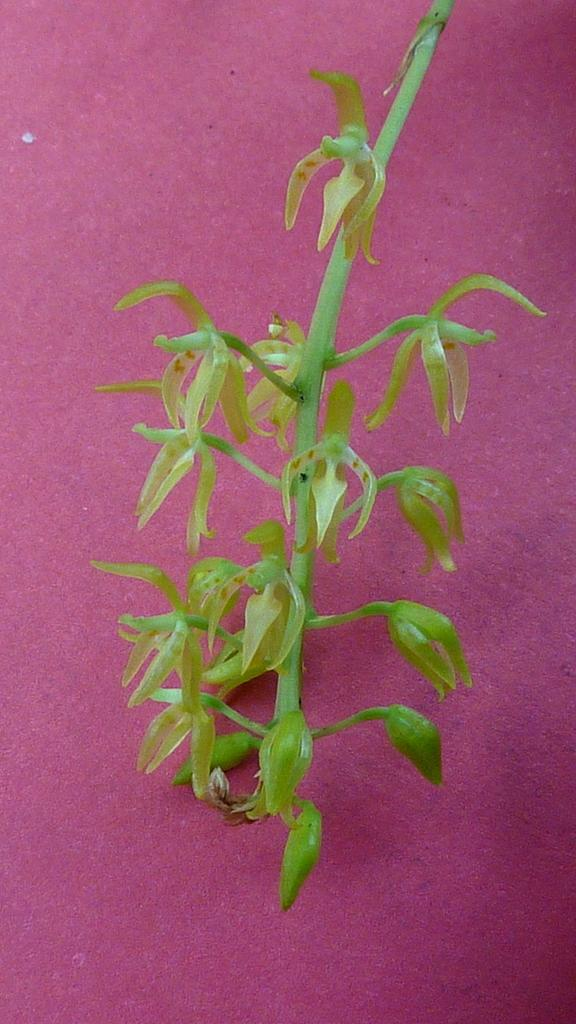What is present in the image? There is a plant in the image. What color is the plant? The plant is green in color. What is the plant placed on? The plant is on a pink surface. Can you see a stranger making an adjustment to the plant in the image? There is no stranger present in the image, nor is anyone making an adjustment to the plant. 